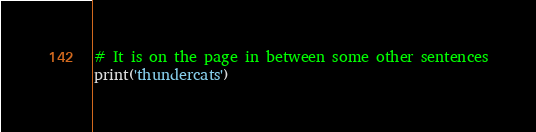Convert code to text. <code><loc_0><loc_0><loc_500><loc_500><_Python_># It is on the page in between some other sentences
print('thundercats')
</code> 